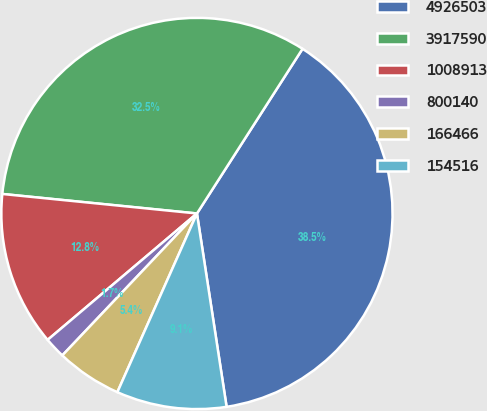Convert chart to OTSL. <chart><loc_0><loc_0><loc_500><loc_500><pie_chart><fcel>4926503<fcel>3917590<fcel>1008913<fcel>800140<fcel>166466<fcel>154516<nl><fcel>38.5%<fcel>32.48%<fcel>12.77%<fcel>1.74%<fcel>5.41%<fcel>9.09%<nl></chart> 